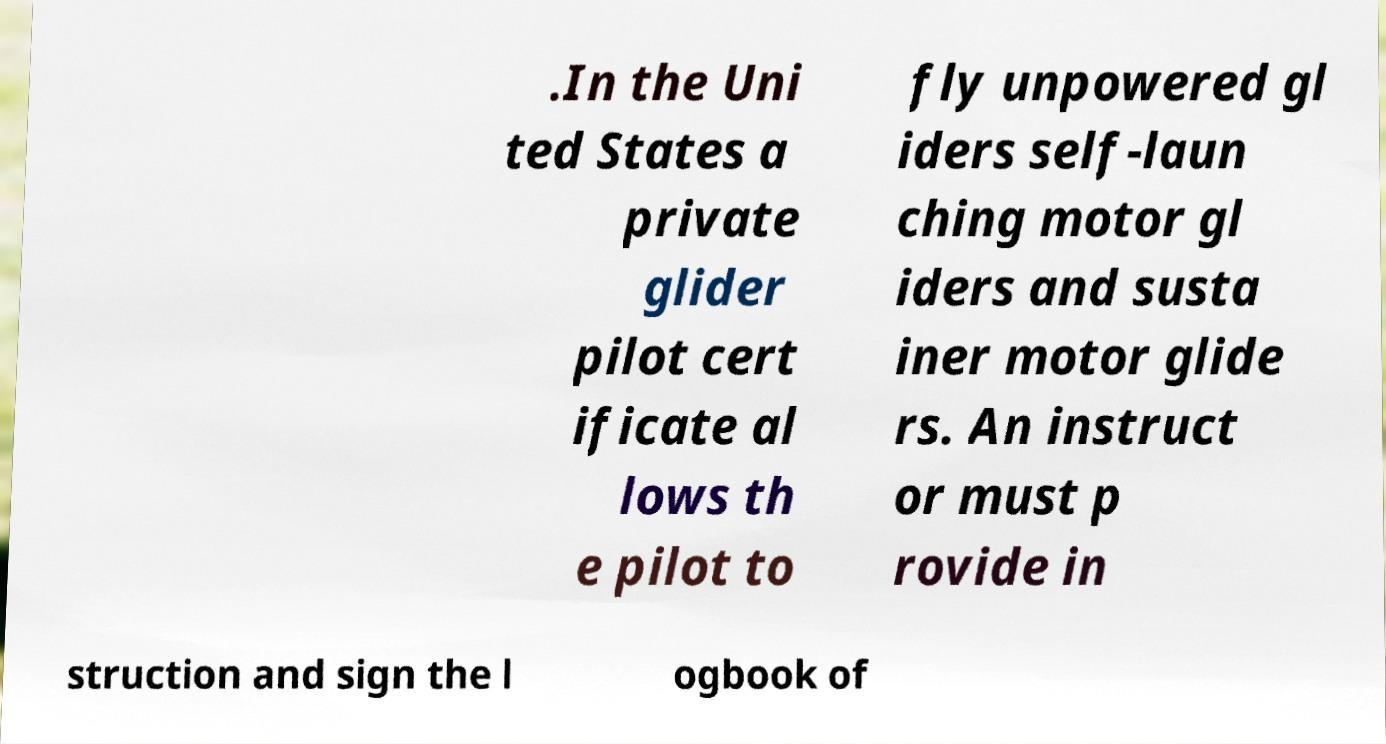What messages or text are displayed in this image? I need them in a readable, typed format. .In the Uni ted States a private glider pilot cert ificate al lows th e pilot to fly unpowered gl iders self-laun ching motor gl iders and susta iner motor glide rs. An instruct or must p rovide in struction and sign the l ogbook of 